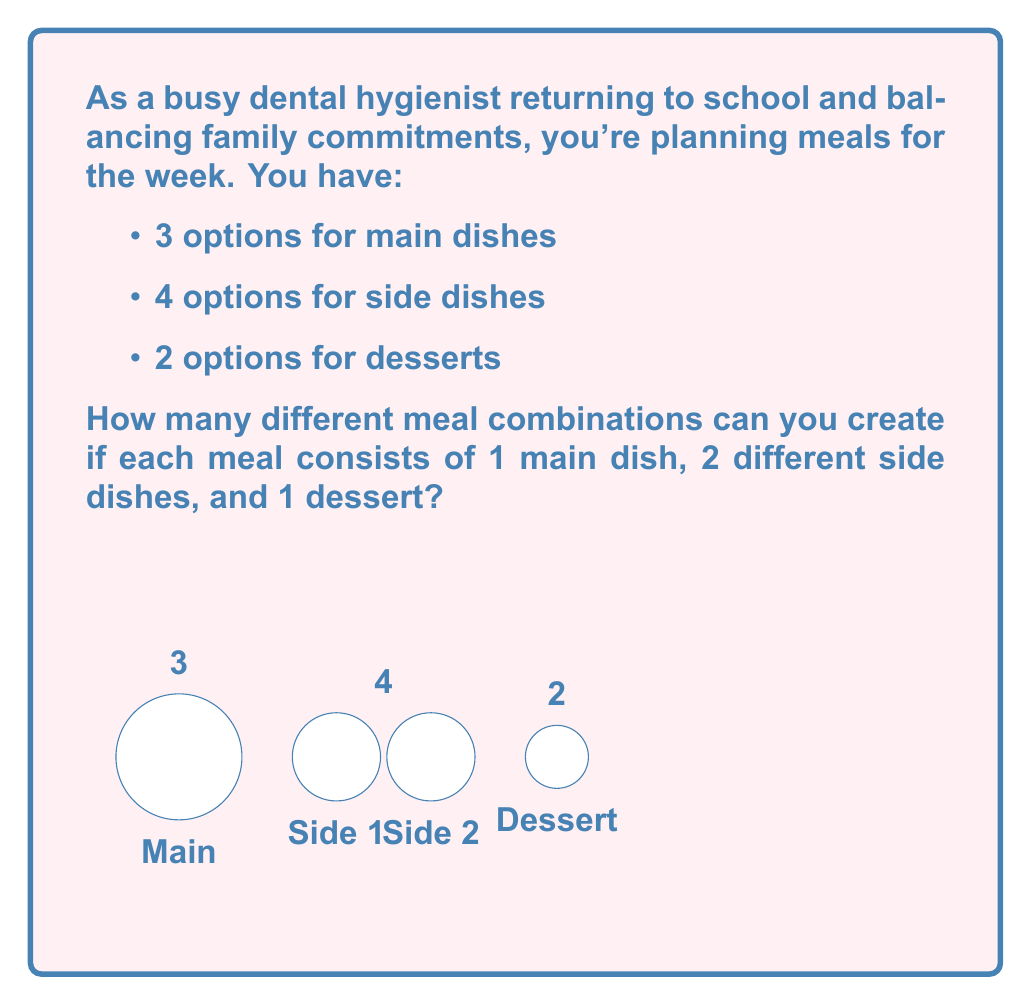Give your solution to this math problem. Let's break this down step-by-step:

1) For the main dish, we have 3 options. This is straightforward.

2) For the first side dish, we can choose any of the 4 options.

3) For the second side dish, we need to choose from the remaining 3 options, as we can't repeat the first side dish.

4) For the dessert, we have 2 options.

5) According to the multiplication principle, we multiply these choices together:

   $$ 3 \times 4 \times 3 \times 2 $$

6) However, the order of selecting the side dishes doesn't matter. For example, selecting side dish A then B is the same meal as selecting B then A. This means we've counted each combination twice.

7) To correct for this, we need to divide our total by 2:

   $$ \frac{3 \times 4 \times 3 \times 2}{2} $$

8) Let's calculate:
   $$ \frac{3 \times 4 \times 3 \times 2}{2} = \frac{72}{2} = 36 $$

Therefore, you can create 36 different meal combinations.
Answer: 36 combinations 